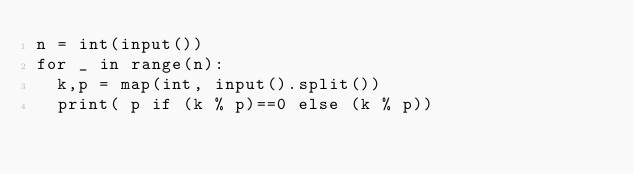<code> <loc_0><loc_0><loc_500><loc_500><_Python_>n = int(input())
for _ in range(n):
  k,p = map(int, input().split())
  print( p if (k % p)==0 else (k % p))
</code> 